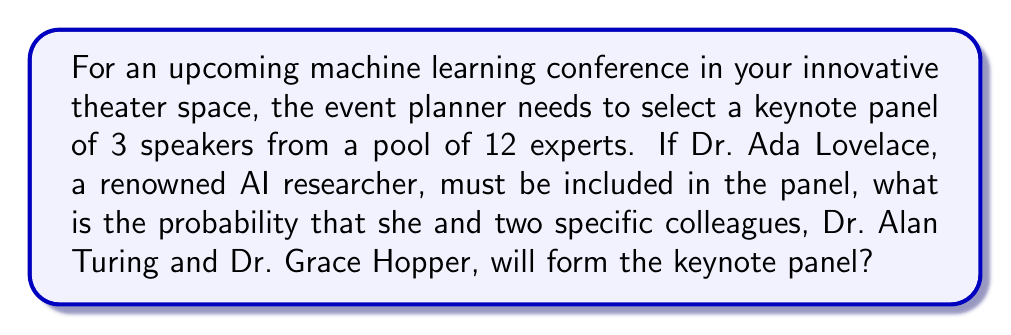Could you help me with this problem? Let's approach this step-by-step:

1) First, we need to understand what the question is asking. We're looking for the probability of selecting a specific group of 3 speakers (Ada Lovelace, Alan Turing, and Grace Hopper) out of 12 experts, given that Ada Lovelace must be included.

2) Since Ada Lovelace must be included, we only need to calculate the probability of selecting the other two specific speakers from the remaining 11 experts.

3) This is a combination problem. We can use the following formula:

   $$P(\text{specific group}) = \frac{\text{number of ways to select the specific group}}{\text{total number of possible groups}}$$

4) The number of ways to select the specific group (Turing and Hopper) from the remaining 11 experts is just 1, as there's only one way to select these two specific people.

5) The total number of possible groups is the number of ways to select 2 people from 11, which is given by the combination formula:

   $$\binom{11}{2} = \frac{11!}{2!(11-2)!} = \frac{11!}{2!(9)!} = 55$$

6) Therefore, the probability is:

   $$P(\text{Turing and Hopper}) = \frac{1}{55}$$
Answer: $\frac{1}{55}$ 